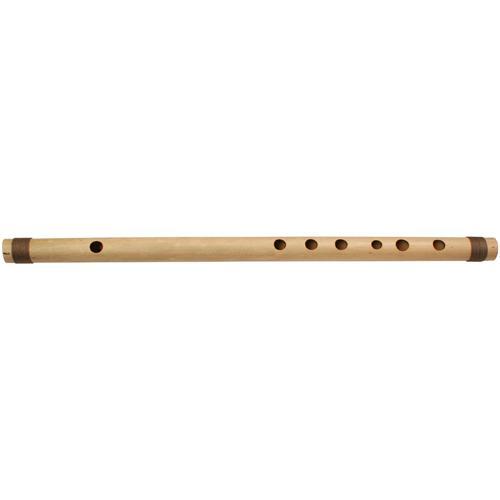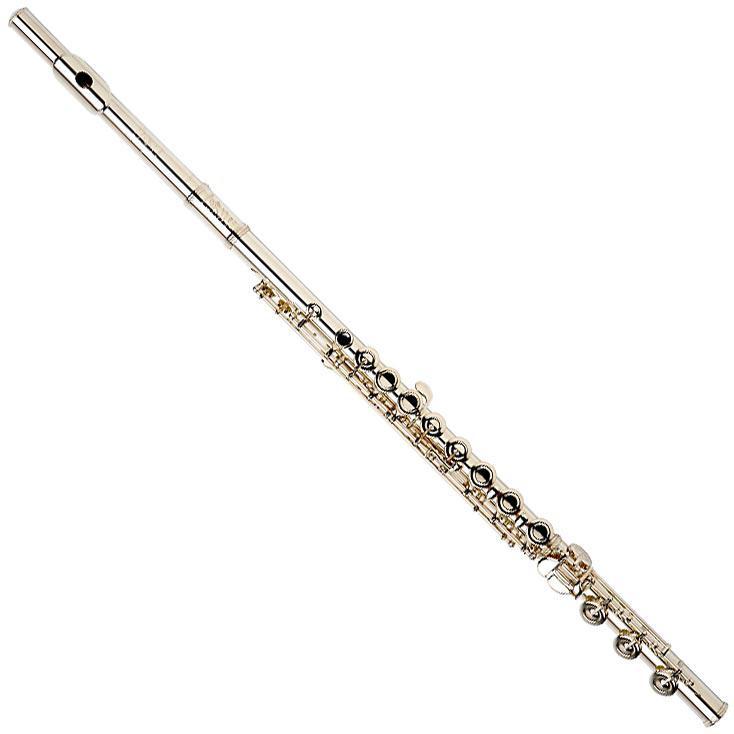The first image is the image on the left, the second image is the image on the right. For the images displayed, is the sentence "There are two flutes." factually correct? Answer yes or no. Yes. The first image is the image on the left, the second image is the image on the right. Evaluate the accuracy of this statement regarding the images: "One writing implement is visible.". Is it true? Answer yes or no. No. 